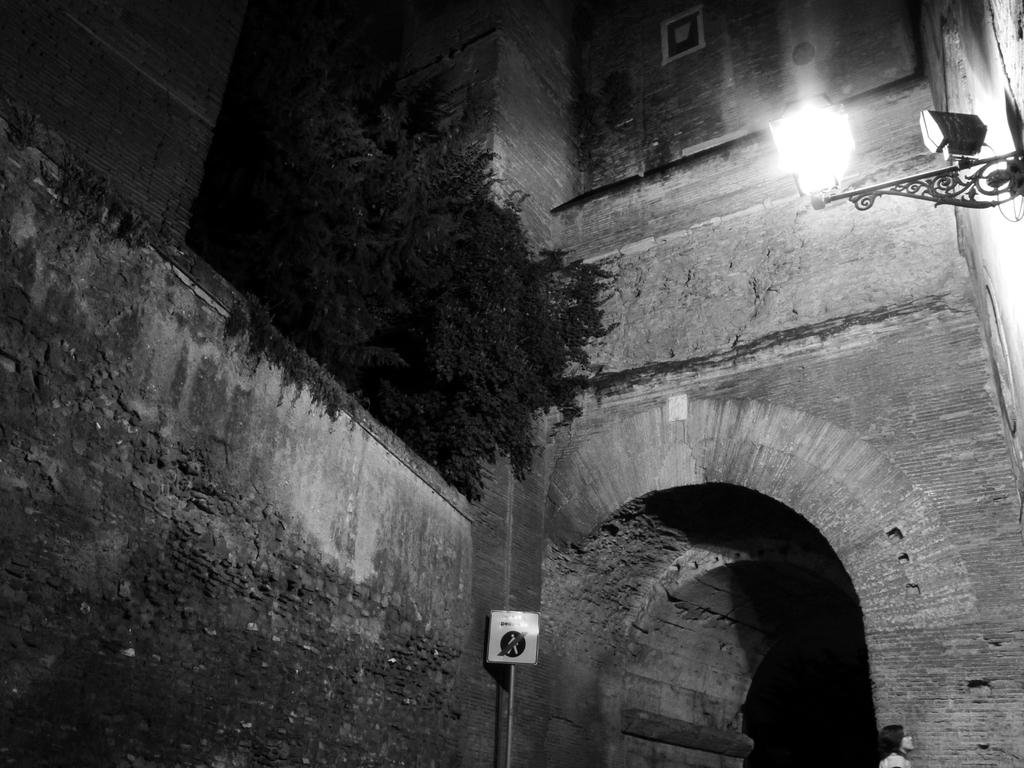What is located in the foreground of the image? There is an arch, a sign board, a wall, and a woman in the foreground of the image. Can you describe the sign board in the image? The sign board is located in the foreground of the image. What is visible on top of the image? There is a lamp, plants, and a wall on top of the image. Can you see any ants crawling on the wall in the image? There is no mention of ants in the provided facts, so we cannot determine if any are present in the image. What type of brick is used to construct the wall in the image? The provided facts do not mention the type of brick used to construct the wall, so we cannot determine this information. 